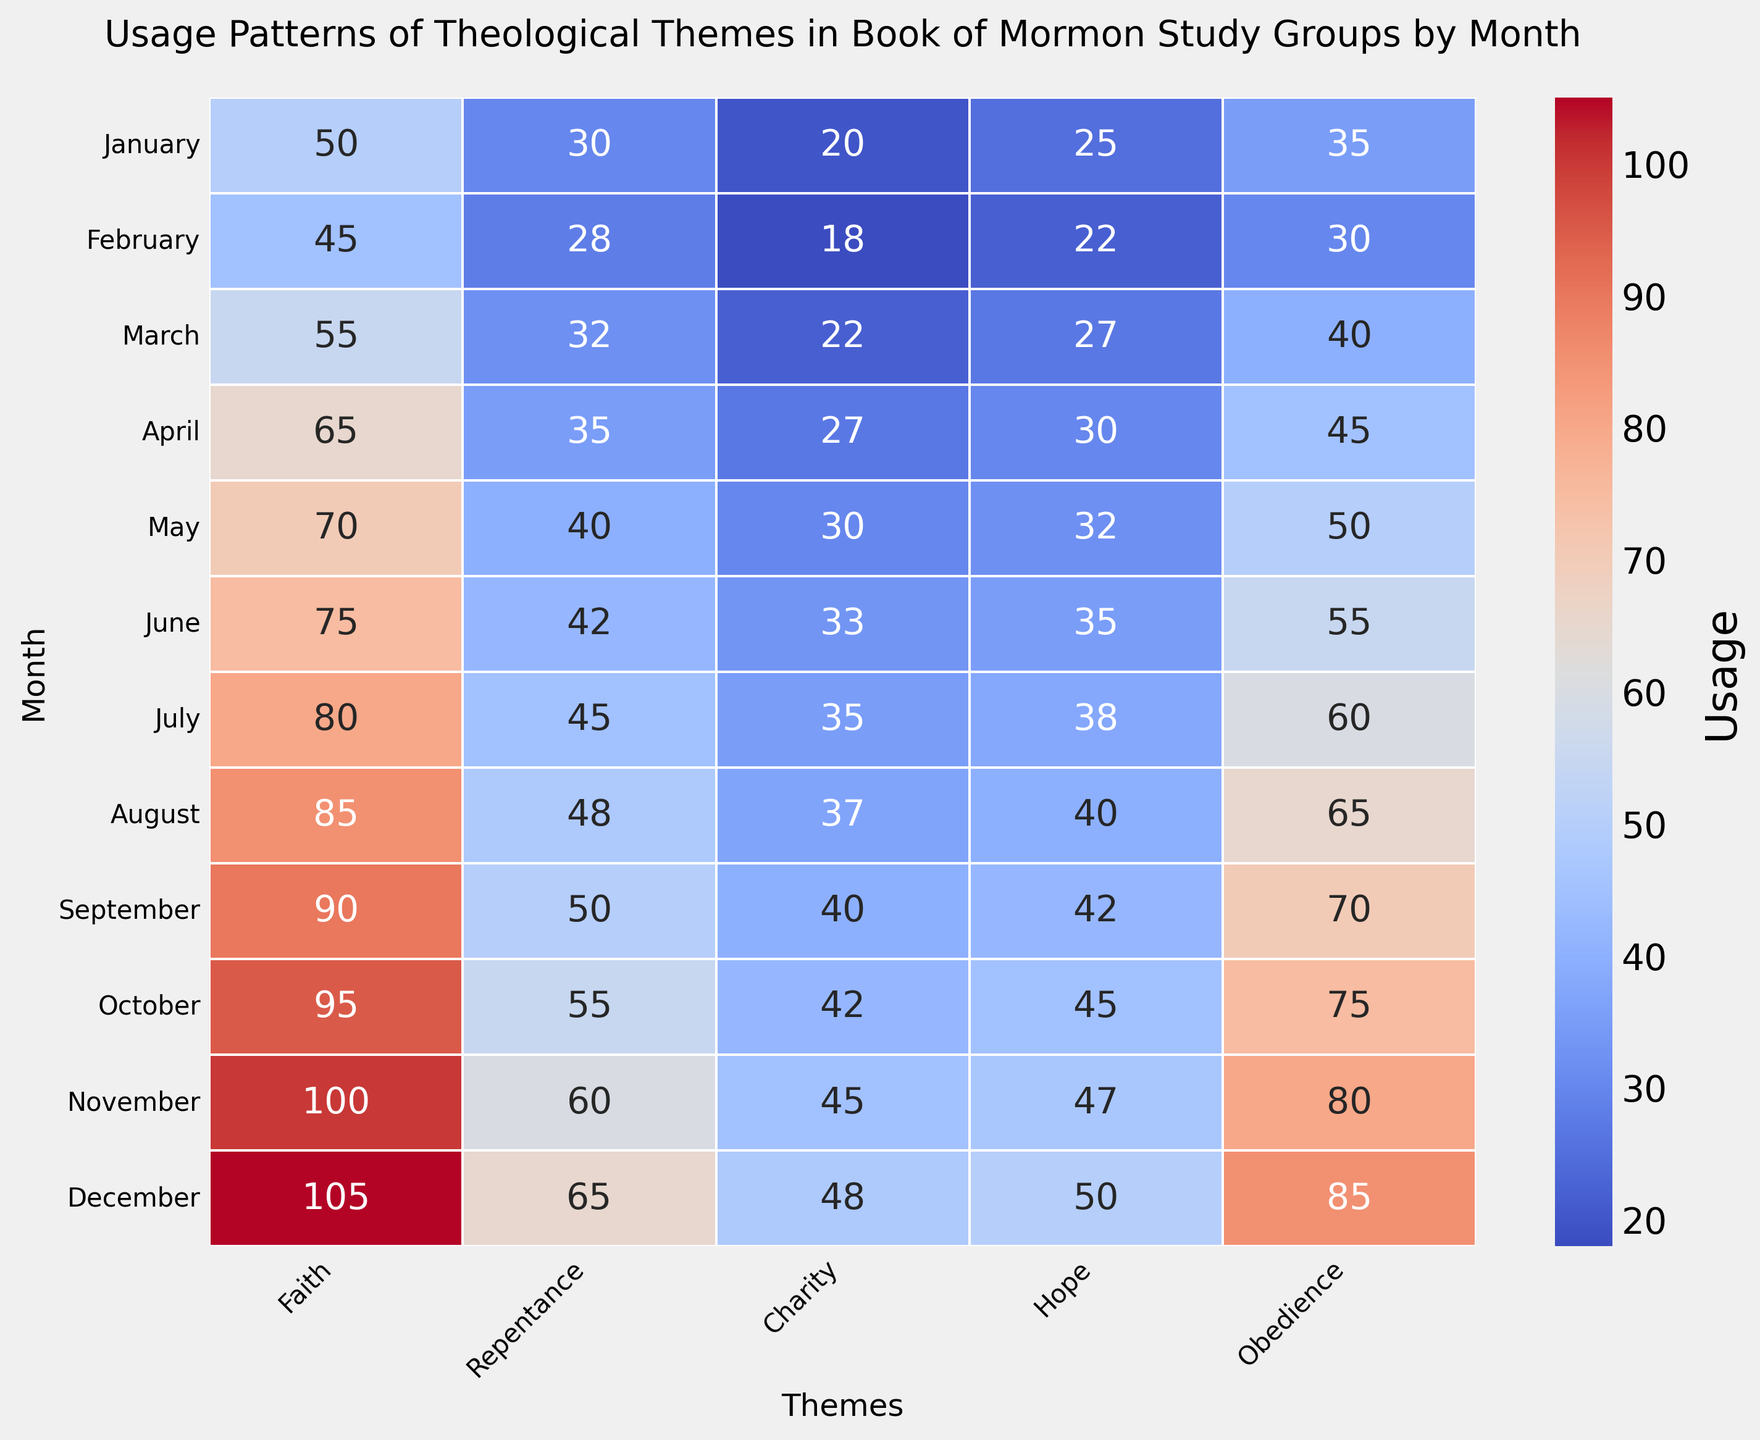What is the highest usage value for the theme "Faith"? Locate the "Faith" column in the heatmap and identify the maximum value present. Here, the value is at the intersection of December and "Faith".
Answer: 105 How does the usage of "Repentance" change from January to December? Observe the values in the "Repentance" column from January to December and calculate the change. The value in January is 30, and in December, it is 65. Therefore, the change is 65 - 30 = 35.
Answer: Increased by 35 Which month shows the highest combined usage of "Charity" and "Hope"? For each month, sum the values for "Charity" and "Hope". Identify the month with the highest sum. For example, in December, the values are 48 (Charity) + 50 (Hope) = 98, which is the highest summed value.
Answer: December Does the theme "Obedience" generally have higher usage in the second half of the year compared to the first half? Compute the average usage of "Obedience" from January to June and from July to December. From January to June, the values are 35, 30, 40, 45, 50, and 55, with an average of (35+30+40+45+50+55)/6 = 42.5. From July to December, the values are 60, 65, 70, 75, 80, and 85, with an average of (60+65+70+75+80+85)/6 = 72.5. Since 72.5 > 42.5, "Obedience" has higher usage in the second half.
Answer: Yes Which theme showed the greatest increase in usage from January to December? Calculate the difference between the values in January and December for each theme. The increases are 105-50=55, 65-30=35, 48-20=28, 50-25=25, and 85-35=50 for "Faith", "Repentance", "Charity", "Hope", and "Obedience" respectively. "Faith" has the greatest increase of 55.
Answer: Faith By how much did the usage of "Hope" increase from March to November? Identify the values for "Hope" in March and November, which are 27 and 47 respectively. The increase is calculated as 47 - 27 = 20.
Answer: 20 During which month do all themes except "Faith" have their lowest usage values? Identify the lowest value for each theme except "Faith" and check the respective months. For "Repentance" (28), "Charity" (18), "Hope" (22), and "Obedience" (30), these values all occur in February.
Answer: February Which theme has the smallest overall variation in usage throughout the year? Calculate the range for each theme (highest value - lowest value). The ranges are 105-50=55 for "Faith", 65-28=37 for "Repentance", 48-18=30 for "Charity", 50-22=28 for "Hope", and 85-30=55 for "Obedience". "Hope" has the smallest variation of 28.
Answer: Hope 